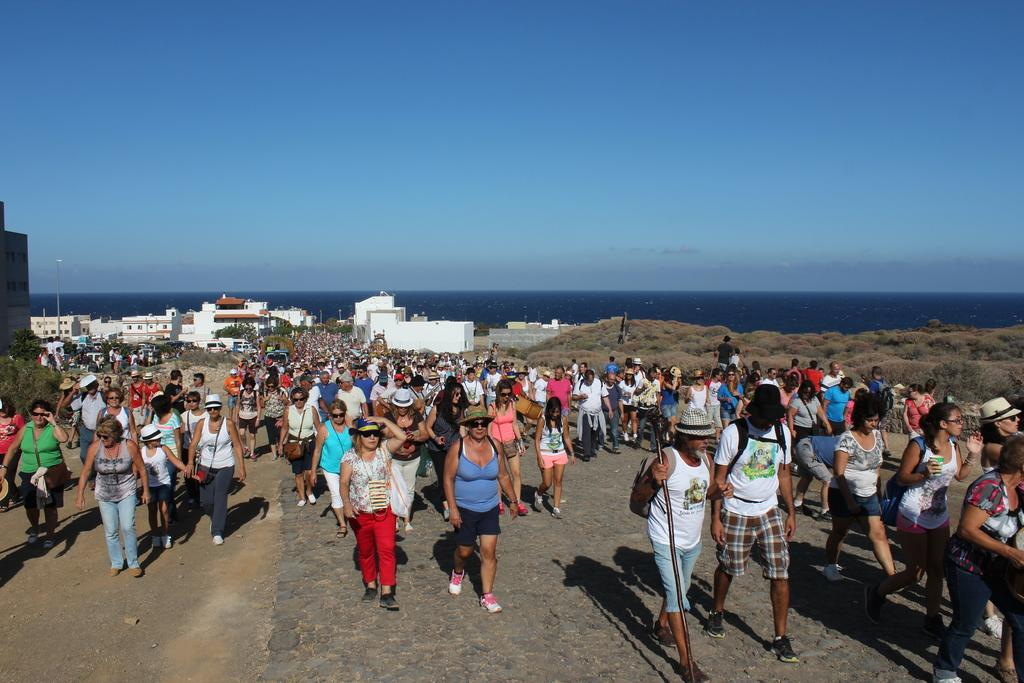What are the people in the image doing? There are many persons walking on the road in the image. What can be seen in the background of the image? There are trees, buildings, plants, grass, water, poles, and the sky visible in the background of the image. What is the condition of the sky in the image? The sky is visible in the background of the image, and there are clouds present. What direction are the people walking in the image? The direction in which the people are walking cannot be determined from the image. Can you see a snake in the image? There is no snake present in the image. 